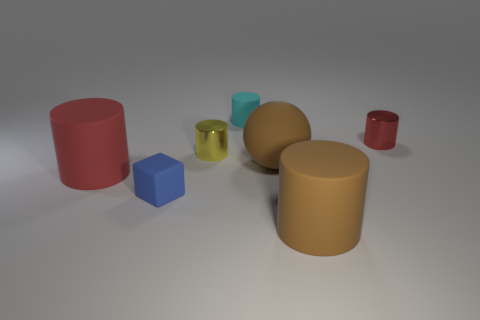Can you describe the arrangement of shapes seen in this image? The image shows an aesthetically pleasing arrangement of geometric shapes with varying colors and textures. From left to right, there's a matte red cylinder, a smaller, shiny, translucent cube in a greenish hue, a matte, small blue cube, a large matte tan sphere, and finally a small glossy red cylinder. 